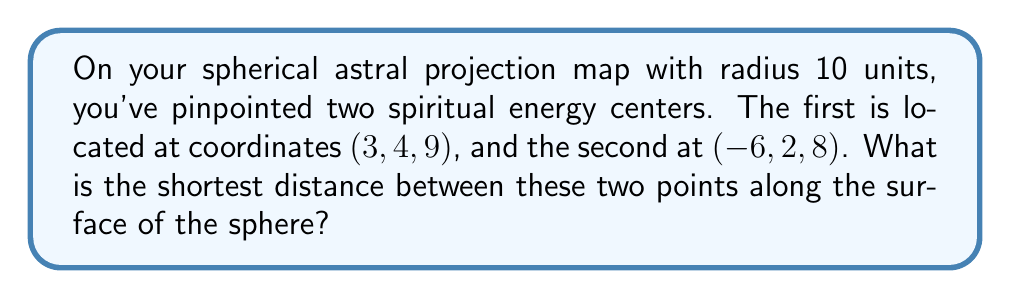Can you answer this question? To solve this problem, we'll use the following steps:

1) First, we need to calculate the central angle between the two points. We can do this using the dot product formula for spherical coordinates:

   $$\cos \theta = \frac{x_1x_2 + y_1y_2 + z_1z_2}{r^2}$$

   where $(x_1, y_1, z_1)$ and $(x_2, y_2, z_2)$ are the coordinates of the two points, and $r$ is the radius of the sphere.

2) Plugging in our values:

   $$\cos \theta = \frac{(3)(-6) + (4)(2) + (9)(8)}{10^2} = \frac{-18 + 8 + 72}{100} = \frac{62}{100} = 0.62$$

3) Now we can find $\theta$ by taking the inverse cosine (arccos):

   $$\theta = \arccos(0.62) \approx 0.9273 \text{ radians}$$

4) The distance along the great circle (the shortest path on the surface of the sphere) is given by the arc length formula:

   $$s = r\theta$$

   where $r$ is the radius and $\theta$ is in radians.

5) Substituting our values:

   $$s = 10 * 0.9273 \approx 9.273 \text{ units}$$

Therefore, the shortest distance between the two spiritual energy centers along the surface of the astral projection map is approximately 9.273 units.
Answer: 9.273 units 